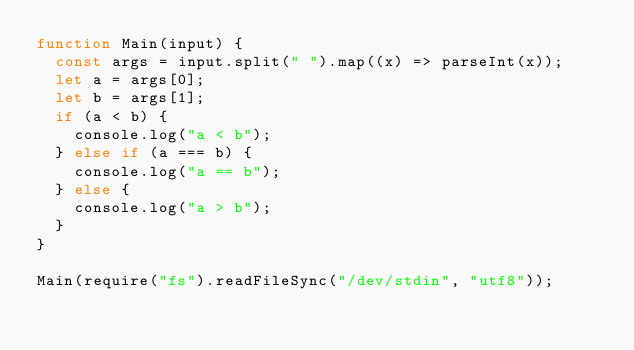Convert code to text. <code><loc_0><loc_0><loc_500><loc_500><_JavaScript_>function Main(input) {
  const args = input.split(" ").map((x) => parseInt(x));
  let a = args[0];
  let b = args[1];
  if (a < b) {
    console.log("a < b");
  } else if (a === b) {
    console.log("a == b");
  } else {
    console.log("a > b");
  }
}

Main(require("fs").readFileSync("/dev/stdin", "utf8"));
</code> 